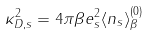Convert formula to latex. <formula><loc_0><loc_0><loc_500><loc_500>\kappa _ { D , s } ^ { 2 } = 4 \pi \beta e _ { s } ^ { 2 } \langle n _ { s } \rangle _ { \beta } ^ { ( 0 ) }</formula> 